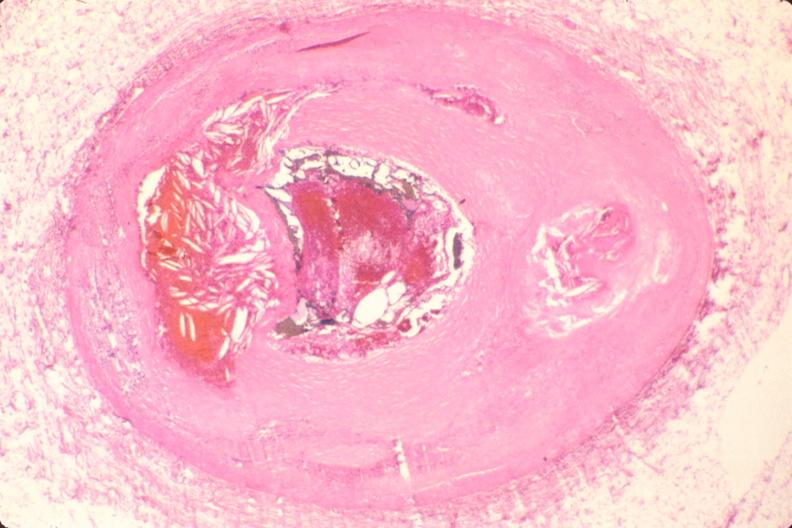s nodular tumor present?
Answer the question using a single word or phrase. No 